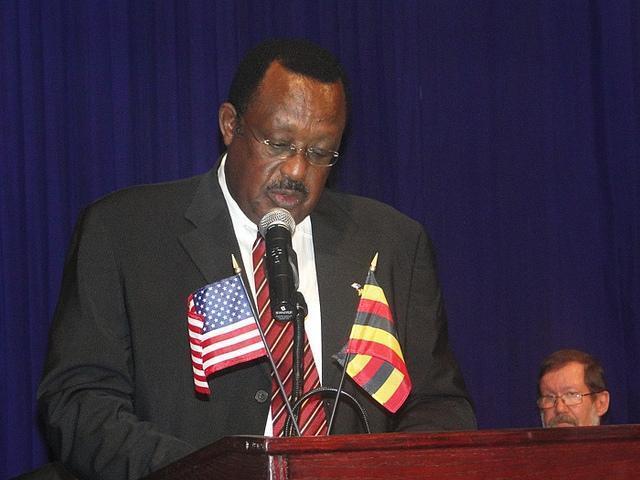How many people are there?
Give a very brief answer. 2. 